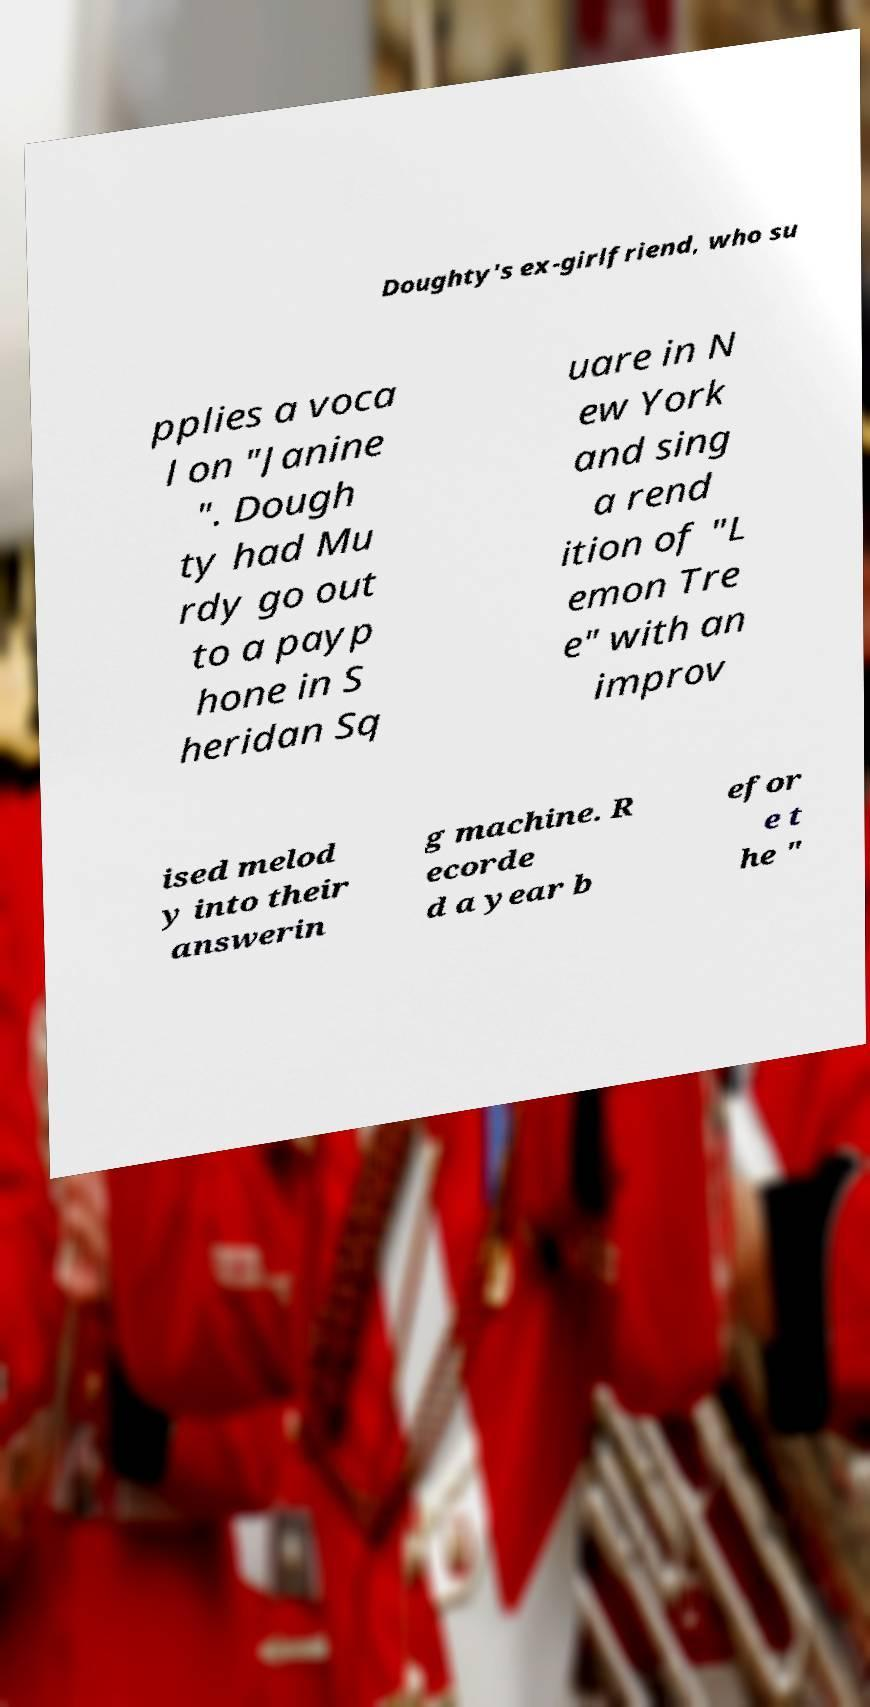Could you extract and type out the text from this image? Doughty's ex-girlfriend, who su pplies a voca l on "Janine ". Dough ty had Mu rdy go out to a payp hone in S heridan Sq uare in N ew York and sing a rend ition of "L emon Tre e" with an improv ised melod y into their answerin g machine. R ecorde d a year b efor e t he " 